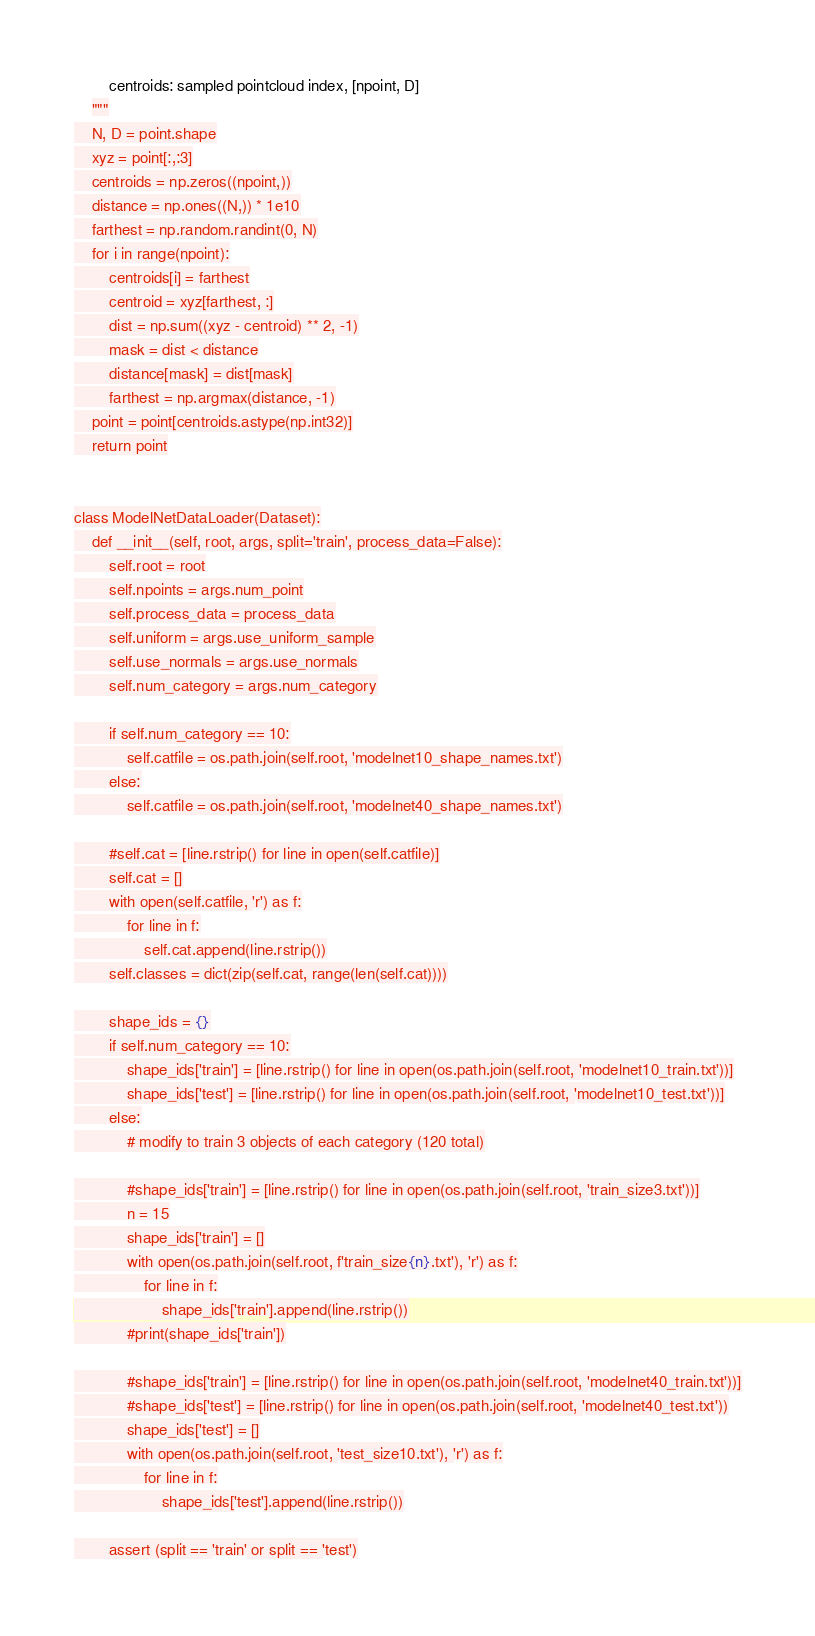Convert code to text. <code><loc_0><loc_0><loc_500><loc_500><_Python_>        centroids: sampled pointcloud index, [npoint, D]
    """
    N, D = point.shape
    xyz = point[:,:3]
    centroids = np.zeros((npoint,))
    distance = np.ones((N,)) * 1e10
    farthest = np.random.randint(0, N)
    for i in range(npoint):
        centroids[i] = farthest
        centroid = xyz[farthest, :]
        dist = np.sum((xyz - centroid) ** 2, -1)
        mask = dist < distance
        distance[mask] = dist[mask]
        farthest = np.argmax(distance, -1)
    point = point[centroids.astype(np.int32)]
    return point


class ModelNetDataLoader(Dataset):
    def __init__(self, root, args, split='train', process_data=False):
        self.root = root
        self.npoints = args.num_point
        self.process_data = process_data
        self.uniform = args.use_uniform_sample
        self.use_normals = args.use_normals
        self.num_category = args.num_category

        if self.num_category == 10:
            self.catfile = os.path.join(self.root, 'modelnet10_shape_names.txt')
        else:
            self.catfile = os.path.join(self.root, 'modelnet40_shape_names.txt')

        #self.cat = [line.rstrip() for line in open(self.catfile)]
        self.cat = []
        with open(self.catfile, 'r') as f:
            for line in f:
                self.cat.append(line.rstrip())
        self.classes = dict(zip(self.cat, range(len(self.cat))))

        shape_ids = {}
        if self.num_category == 10:
            shape_ids['train'] = [line.rstrip() for line in open(os.path.join(self.root, 'modelnet10_train.txt'))]
            shape_ids['test'] = [line.rstrip() for line in open(os.path.join(self.root, 'modelnet10_test.txt'))]
        else:
            # modify to train 3 objects of each category (120 total)

            #shape_ids['train'] = [line.rstrip() for line in open(os.path.join(self.root, 'train_size3.txt'))]
            n = 15
            shape_ids['train'] = []
            with open(os.path.join(self.root, f'train_size{n}.txt'), 'r') as f:
                for line in f:
                    shape_ids['train'].append(line.rstrip())
            #print(shape_ids['train'])

            #shape_ids['train'] = [line.rstrip() for line in open(os.path.join(self.root, 'modelnet40_train.txt'))]
            #shape_ids['test'] = [line.rstrip() for line in open(os.path.join(self.root, 'modelnet40_test.txt'))
            shape_ids['test'] = []
            with open(os.path.join(self.root, 'test_size10.txt'), 'r') as f:
                for line in f:
                    shape_ids['test'].append(line.rstrip())

        assert (split == 'train' or split == 'test')</code> 